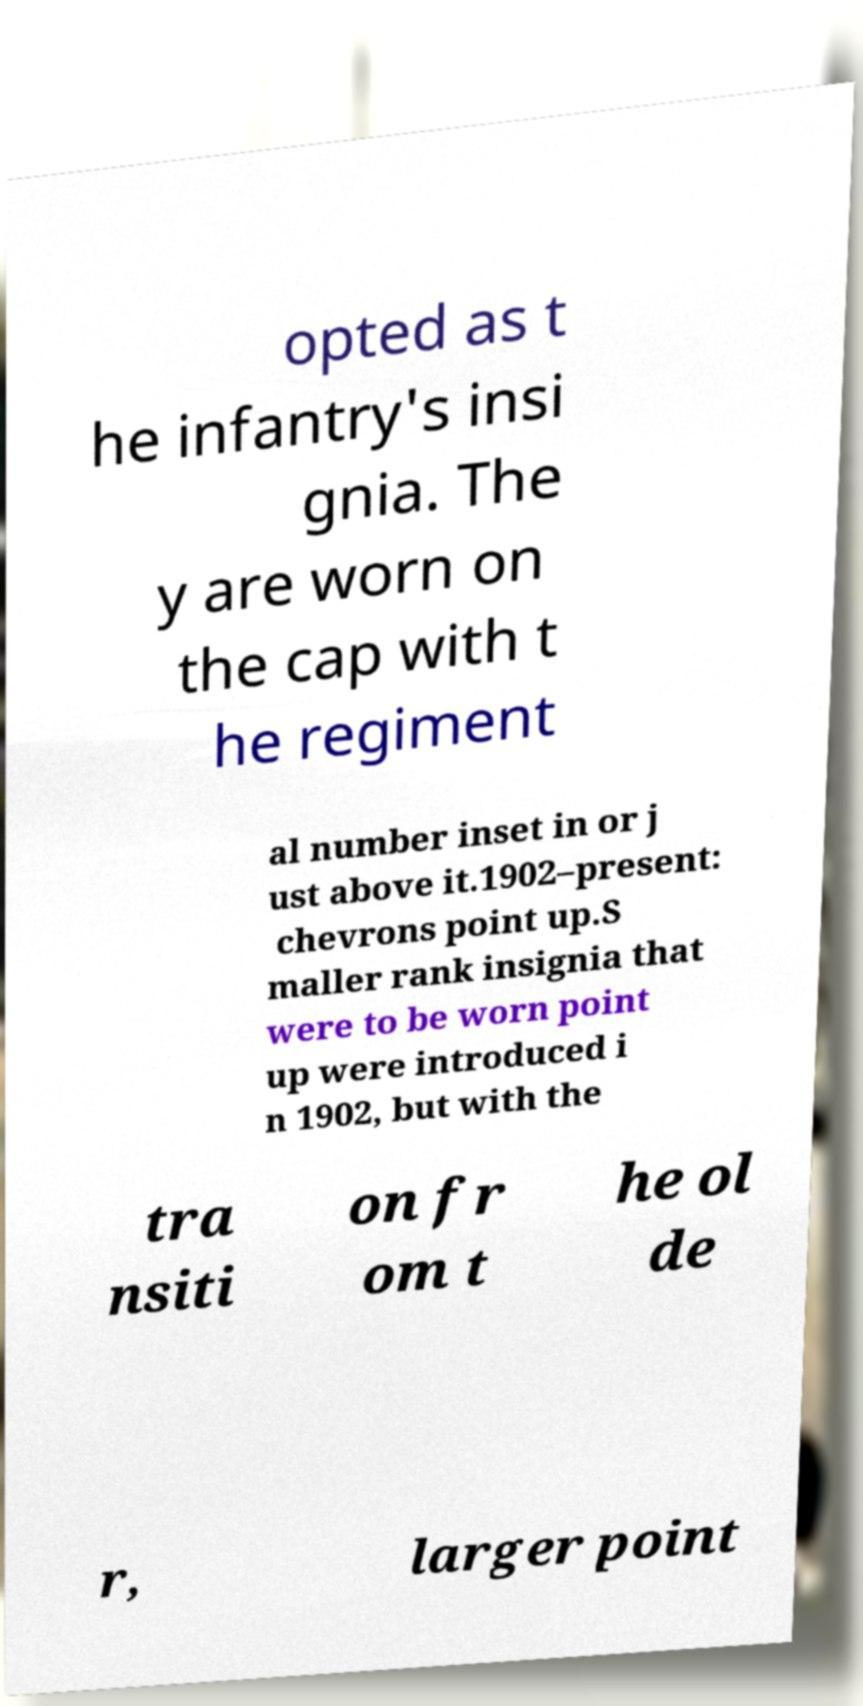Can you accurately transcribe the text from the provided image for me? opted as t he infantry's insi gnia. The y are worn on the cap with t he regiment al number inset in or j ust above it.1902–present: chevrons point up.S maller rank insignia that were to be worn point up were introduced i n 1902, but with the tra nsiti on fr om t he ol de r, larger point 